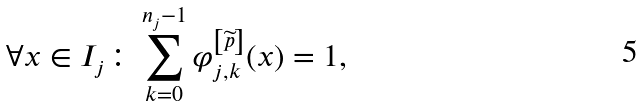<formula> <loc_0><loc_0><loc_500><loc_500>\forall x \in I _ { j } \colon \sum _ { k = 0 } ^ { n _ { j } - 1 } \varphi _ { j , k } ^ { \left [ \widetilde { p } \right ] } ( x ) = 1 ,</formula> 